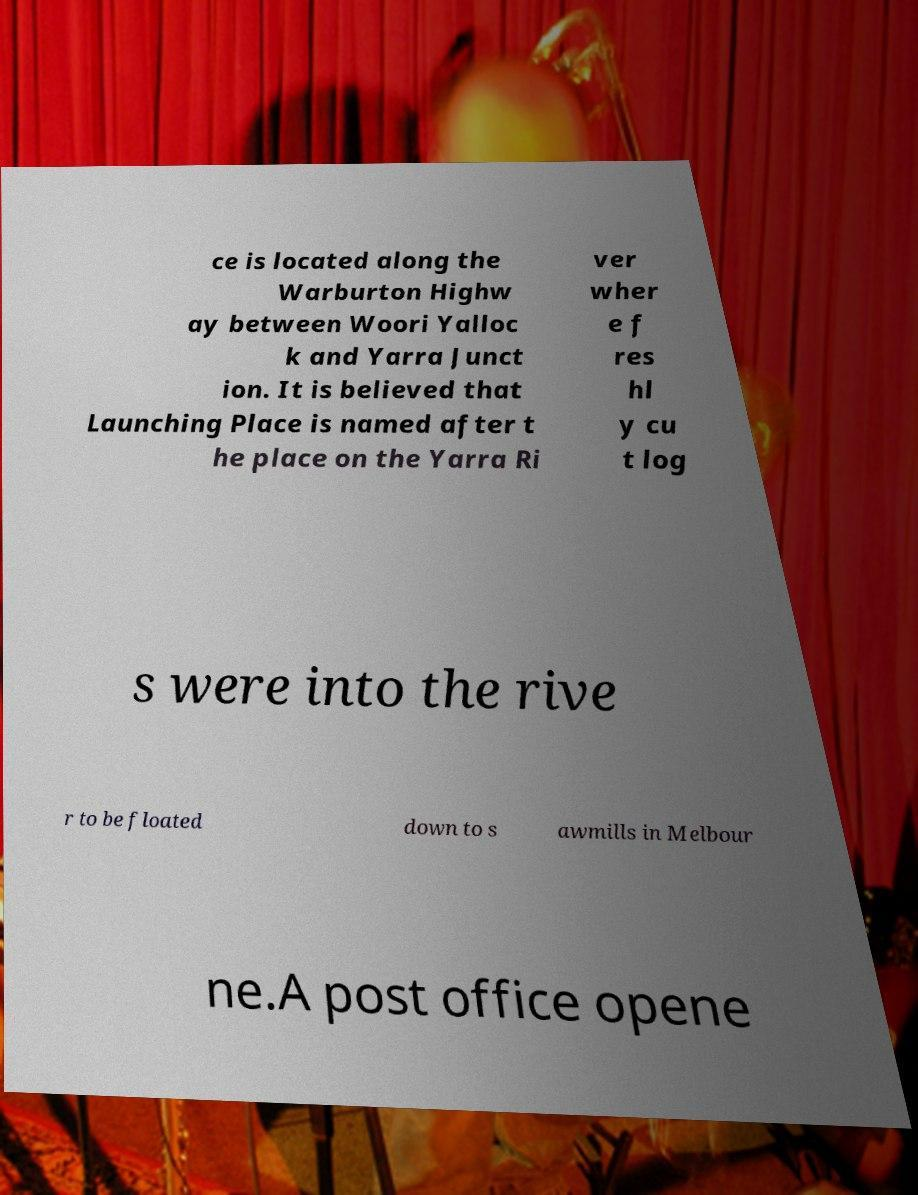I need the written content from this picture converted into text. Can you do that? ce is located along the Warburton Highw ay between Woori Yalloc k and Yarra Junct ion. It is believed that Launching Place is named after t he place on the Yarra Ri ver wher e f res hl y cu t log s were into the rive r to be floated down to s awmills in Melbour ne.A post office opene 